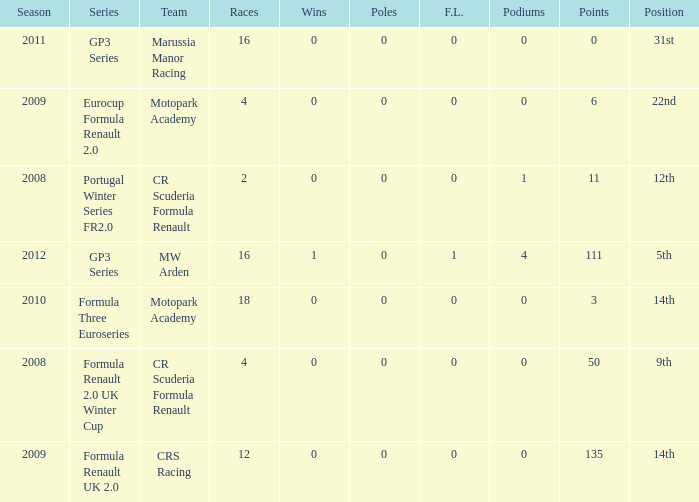What is the least amount of podiums? 0.0. Parse the full table. {'header': ['Season', 'Series', 'Team', 'Races', 'Wins', 'Poles', 'F.L.', 'Podiums', 'Points', 'Position'], 'rows': [['2011', 'GP3 Series', 'Marussia Manor Racing', '16', '0', '0', '0', '0', '0', '31st'], ['2009', 'Eurocup Formula Renault 2.0', 'Motopark Academy', '4', '0', '0', '0', '0', '6', '22nd'], ['2008', 'Portugal Winter Series FR2.0', 'CR Scuderia Formula Renault', '2', '0', '0', '0', '1', '11', '12th'], ['2012', 'GP3 Series', 'MW Arden', '16', '1', '0', '1', '4', '111', '5th'], ['2010', 'Formula Three Euroseries', 'Motopark Academy', '18', '0', '0', '0', '0', '3', '14th'], ['2008', 'Formula Renault 2.0 UK Winter Cup', 'CR Scuderia Formula Renault', '4', '0', '0', '0', '0', '50', '9th'], ['2009', 'Formula Renault UK 2.0', 'CRS Racing', '12', '0', '0', '0', '0', '135', '14th']]} 